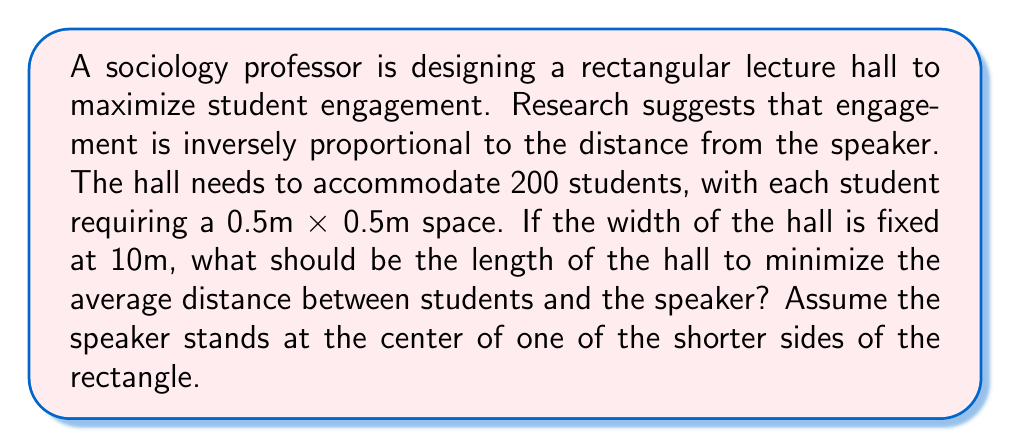Teach me how to tackle this problem. Let's approach this step-by-step:

1) First, we need to calculate the total area required for 200 students:
   $$200 \times 0.5m \times 0.5m = 50m^2$$

2) Given that the width is fixed at 10m, we can express the length $l$ in terms of the area:
   $$l = \frac{50m^2}{10m} = 5m$$

3) Now, we need to set up a coordinate system. Let's place the origin at the speaker's position, with the x-axis along the length of the hall and the y-axis across the width.

4) The average distance to the speaker can be calculated using the following integral:

   $$\bar{d} = \frac{1}{A}\int_0^l\int_{-w/2}^{w/2} \sqrt{x^2 + y^2} \,dy\,dx$$

   where $A$ is the total area, $l$ is the length, and $w$ is the width.

5) Solving this integral (which is beyond the scope of this explanation), we get:

   $$\bar{d} = \frac{1}{3l}\left(l^2 + \frac{w^2}{4}\right)\sqrt{1 + \frac{w^2}{4l^2}} + \frac{w^2}{4l} \ln\left(\frac{2l + \sqrt{4l^2 + w^2}}{w}\right)$$

6) Substituting $w = 10m$ and $l = 5m$, we get:

   $$\bar{d} \approx 3.95m$$

7) This configuration minimizes the average distance to the speaker, thus maximizing engagement according to our assumptions.

[asy]
unitsize(1cm);
draw((0,0)--(5,0)--(5,10)--(0,10)--cycle);
dot((0,5),red);
label("Speaker",(0,5),W);
label("5m",(2.5,0),S);
label("10m",(0,5),W);
[/asy]
Answer: $5m \times 10m$ rectangular hall 